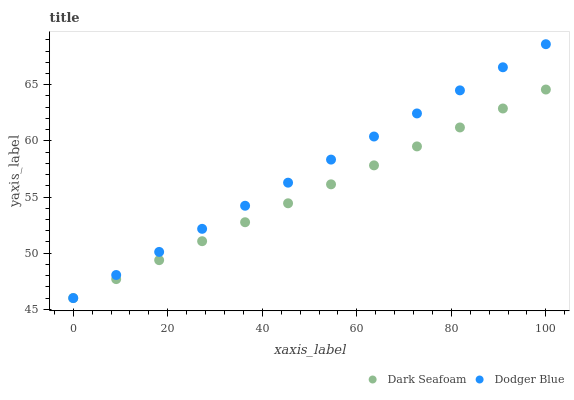Does Dark Seafoam have the minimum area under the curve?
Answer yes or no. Yes. Does Dodger Blue have the maximum area under the curve?
Answer yes or no. Yes. Does Dodger Blue have the minimum area under the curve?
Answer yes or no. No. Is Dark Seafoam the smoothest?
Answer yes or no. Yes. Is Dodger Blue the roughest?
Answer yes or no. Yes. Is Dodger Blue the smoothest?
Answer yes or no. No. Does Dark Seafoam have the lowest value?
Answer yes or no. Yes. Does Dodger Blue have the highest value?
Answer yes or no. Yes. Does Dodger Blue intersect Dark Seafoam?
Answer yes or no. Yes. Is Dodger Blue less than Dark Seafoam?
Answer yes or no. No. Is Dodger Blue greater than Dark Seafoam?
Answer yes or no. No. 